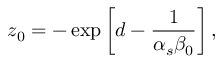<formula> <loc_0><loc_0><loc_500><loc_500>z _ { 0 } = - \exp \left [ d - { \frac { 1 } { \alpha _ { s } \beta _ { 0 } } } \right ] ,</formula> 